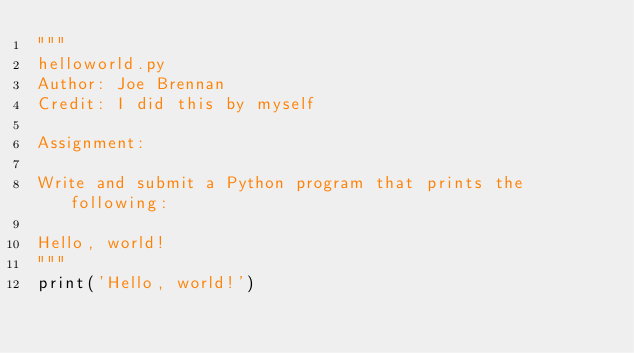Convert code to text. <code><loc_0><loc_0><loc_500><loc_500><_Python_>"""
helloworld.py
Author: Joe Brennan
Credit: I did this by myself

Assignment:

Write and submit a Python program that prints the following:

Hello, world!
"""
print('Hello, world!') 
</code> 